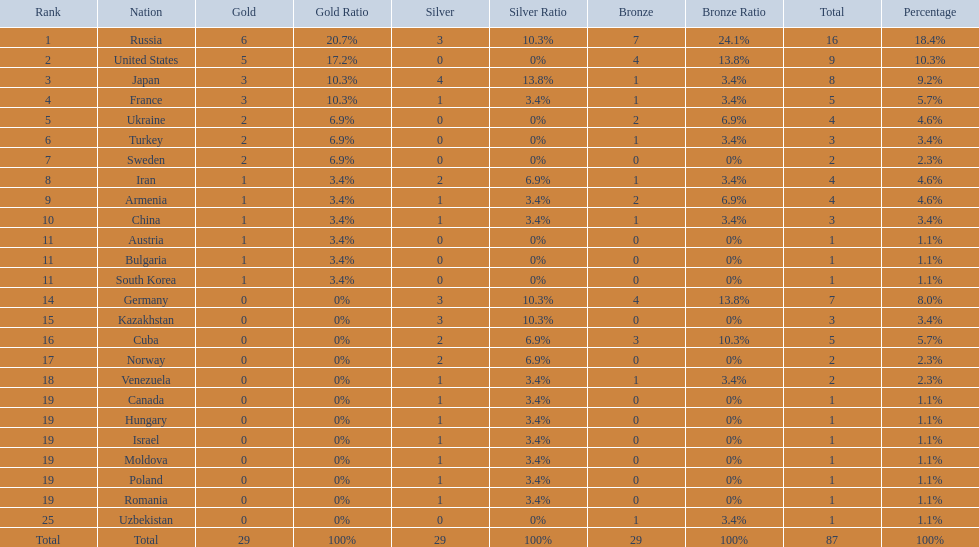Which nations participated in the 1995 world wrestling championships? Russia, United States, Japan, France, Ukraine, Turkey, Sweden, Iran, Armenia, China, Austria, Bulgaria, South Korea, Germany, Kazakhstan, Cuba, Norway, Venezuela, Canada, Hungary, Israel, Moldova, Poland, Romania, Uzbekistan. And between iran and germany, which one placed in the top 10? Germany. 